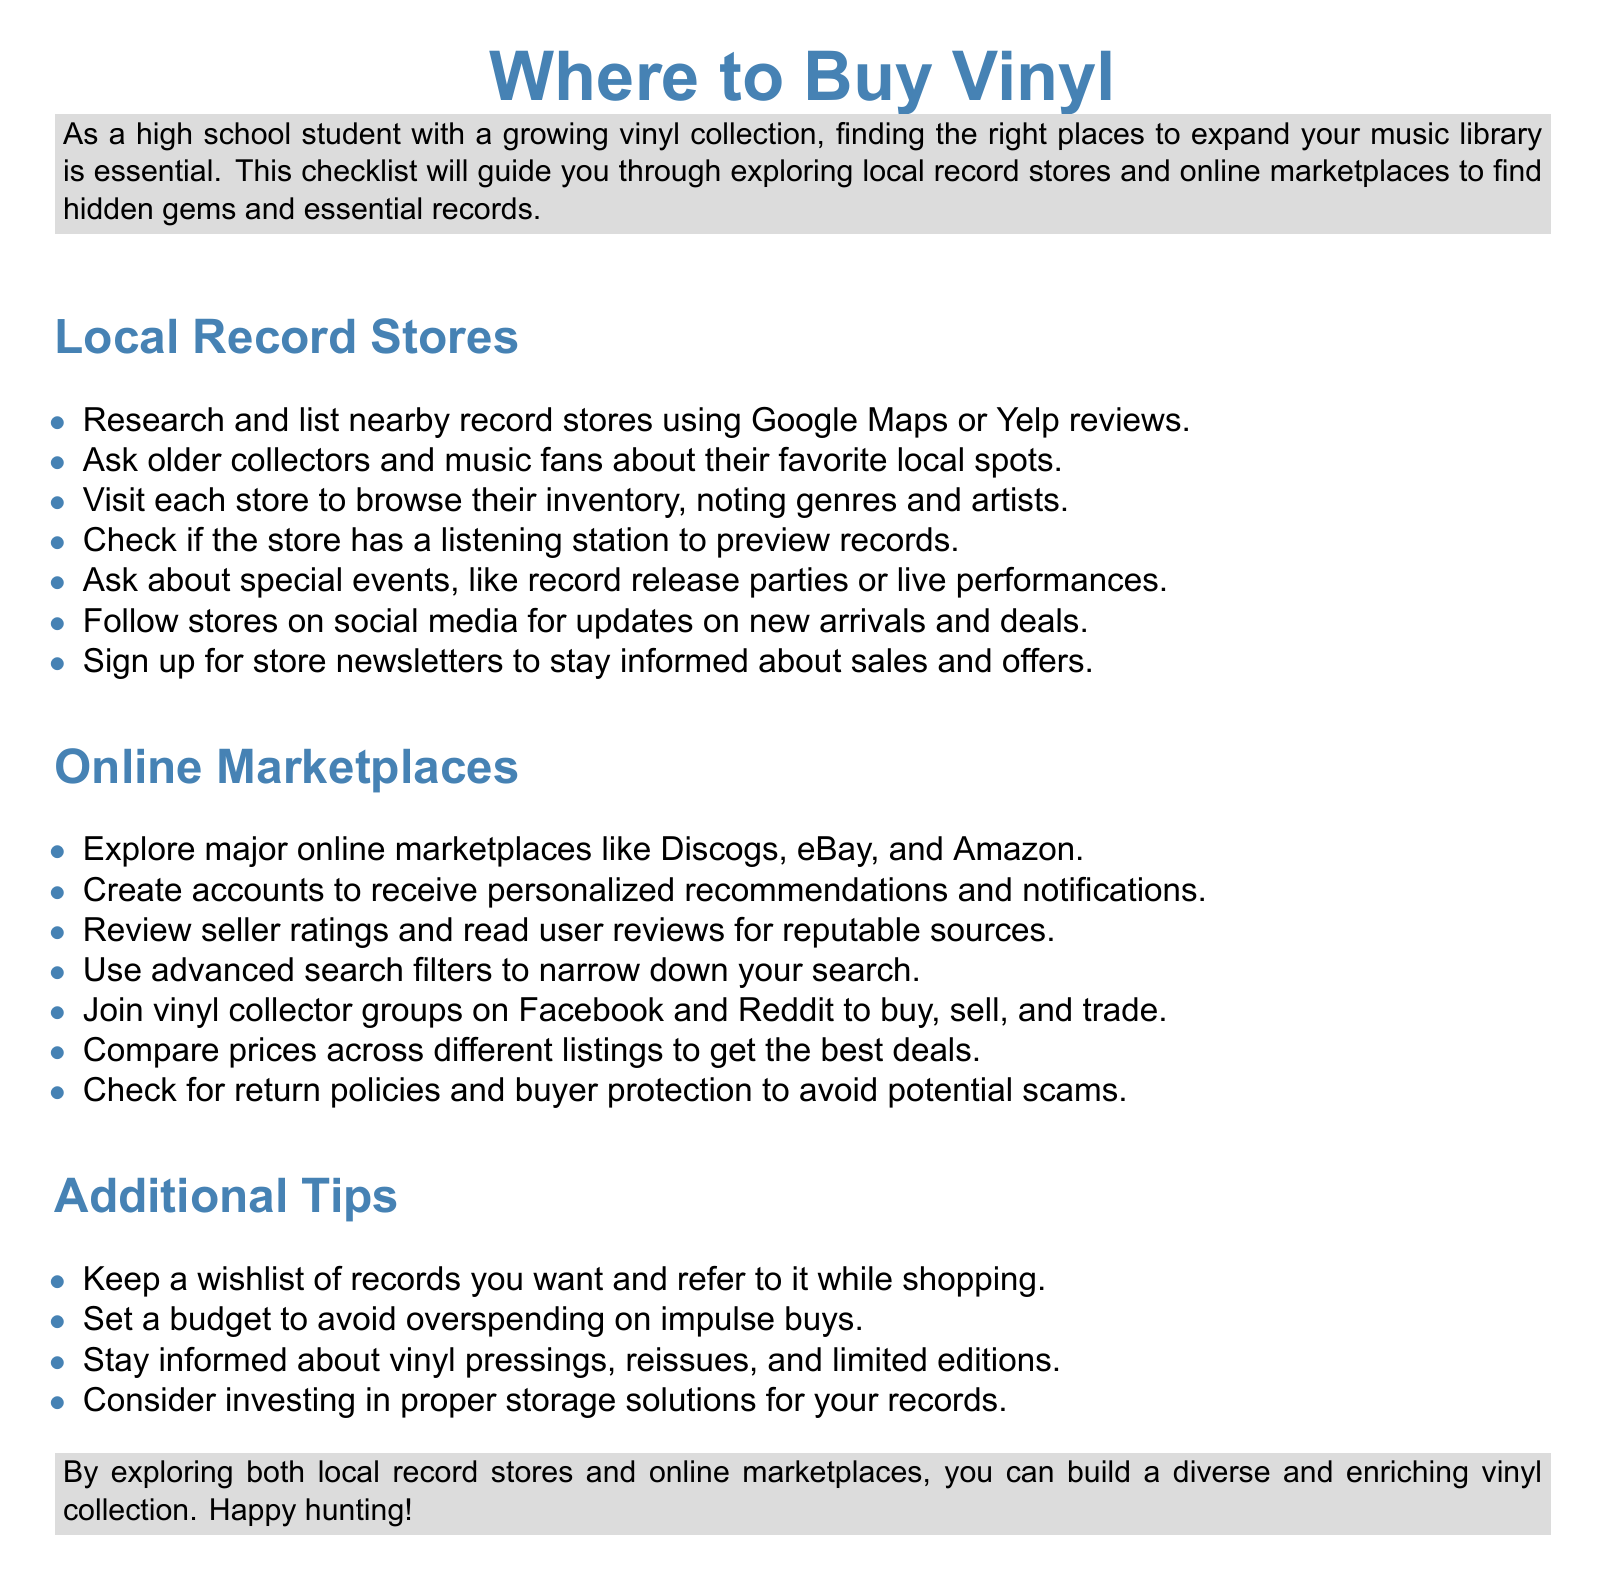what should you research for local record stores? The document suggests researching and listing nearby record stores using Google Maps or Yelp reviews.
Answer: nearby record stores what can you join to buy, sell, and trade vinyl? You can join vinyl collector groups on Facebook and Reddit to buy, sell, and trade vinyl.
Answer: vinyl collector groups how should you stay informed about sales and offers from local stores? You should sign up for store newsletters to stay informed about sales and offers.
Answer: store newsletters what is a key factor to consider when comparing online listings? You should compare prices across different listings to get the best deals.
Answer: prices what should you keep while shopping for records? You should keep a wishlist of records you want while shopping.
Answer: wishlist 